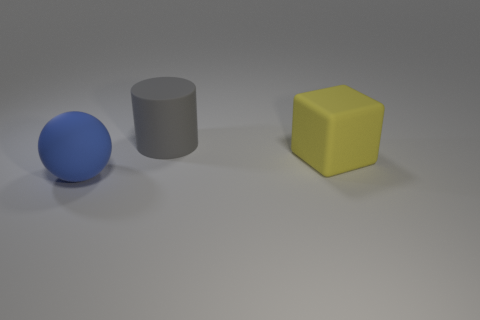Add 2 big balls. How many objects exist? 5 Subtract all cubes. How many objects are left? 2 Subtract all large gray cylinders. Subtract all blocks. How many objects are left? 1 Add 3 blue spheres. How many blue spheres are left? 4 Add 2 matte blocks. How many matte blocks exist? 3 Subtract 0 brown blocks. How many objects are left? 3 